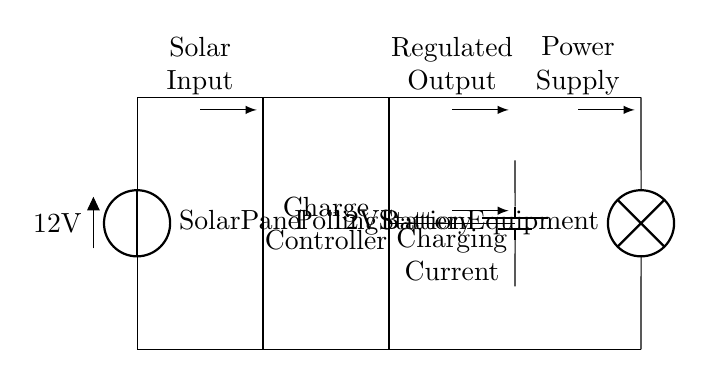What is the voltage of the solar panel? The solar panel provides a voltage of 12 volts as indicated on the diagram.
Answer: 12 volts What is the function of the charge controller? The charge controller regulates the voltage and current flowing to the battery from the solar panel, ensuring the battery is charged safely without overcharging.
Answer: Regulates charging What type of load is connected to this circuit? The load connected is labeled as "Polling Station Equipment," which indicates that it is the equipment used at the polling station.
Answer: Polling Station Equipment How many components are in the circuit? The circuit consists of four components: a solar panel, a charge controller, a battery, and a polling station equipment load.
Answer: Four components What is the purpose of the arrows in the circuit diagram? The arrows indicate the direction of current flow between the components; they show how the solar energy is converted and stored and then used to power the load.
Answer: Indicate current direction What type of battery is used in this circuit? The battery in the circuit is a 12-volt lead-acid battery, as it is a common choice for solar power systems due to its efficiency and durability.
Answer: 12-volt battery 